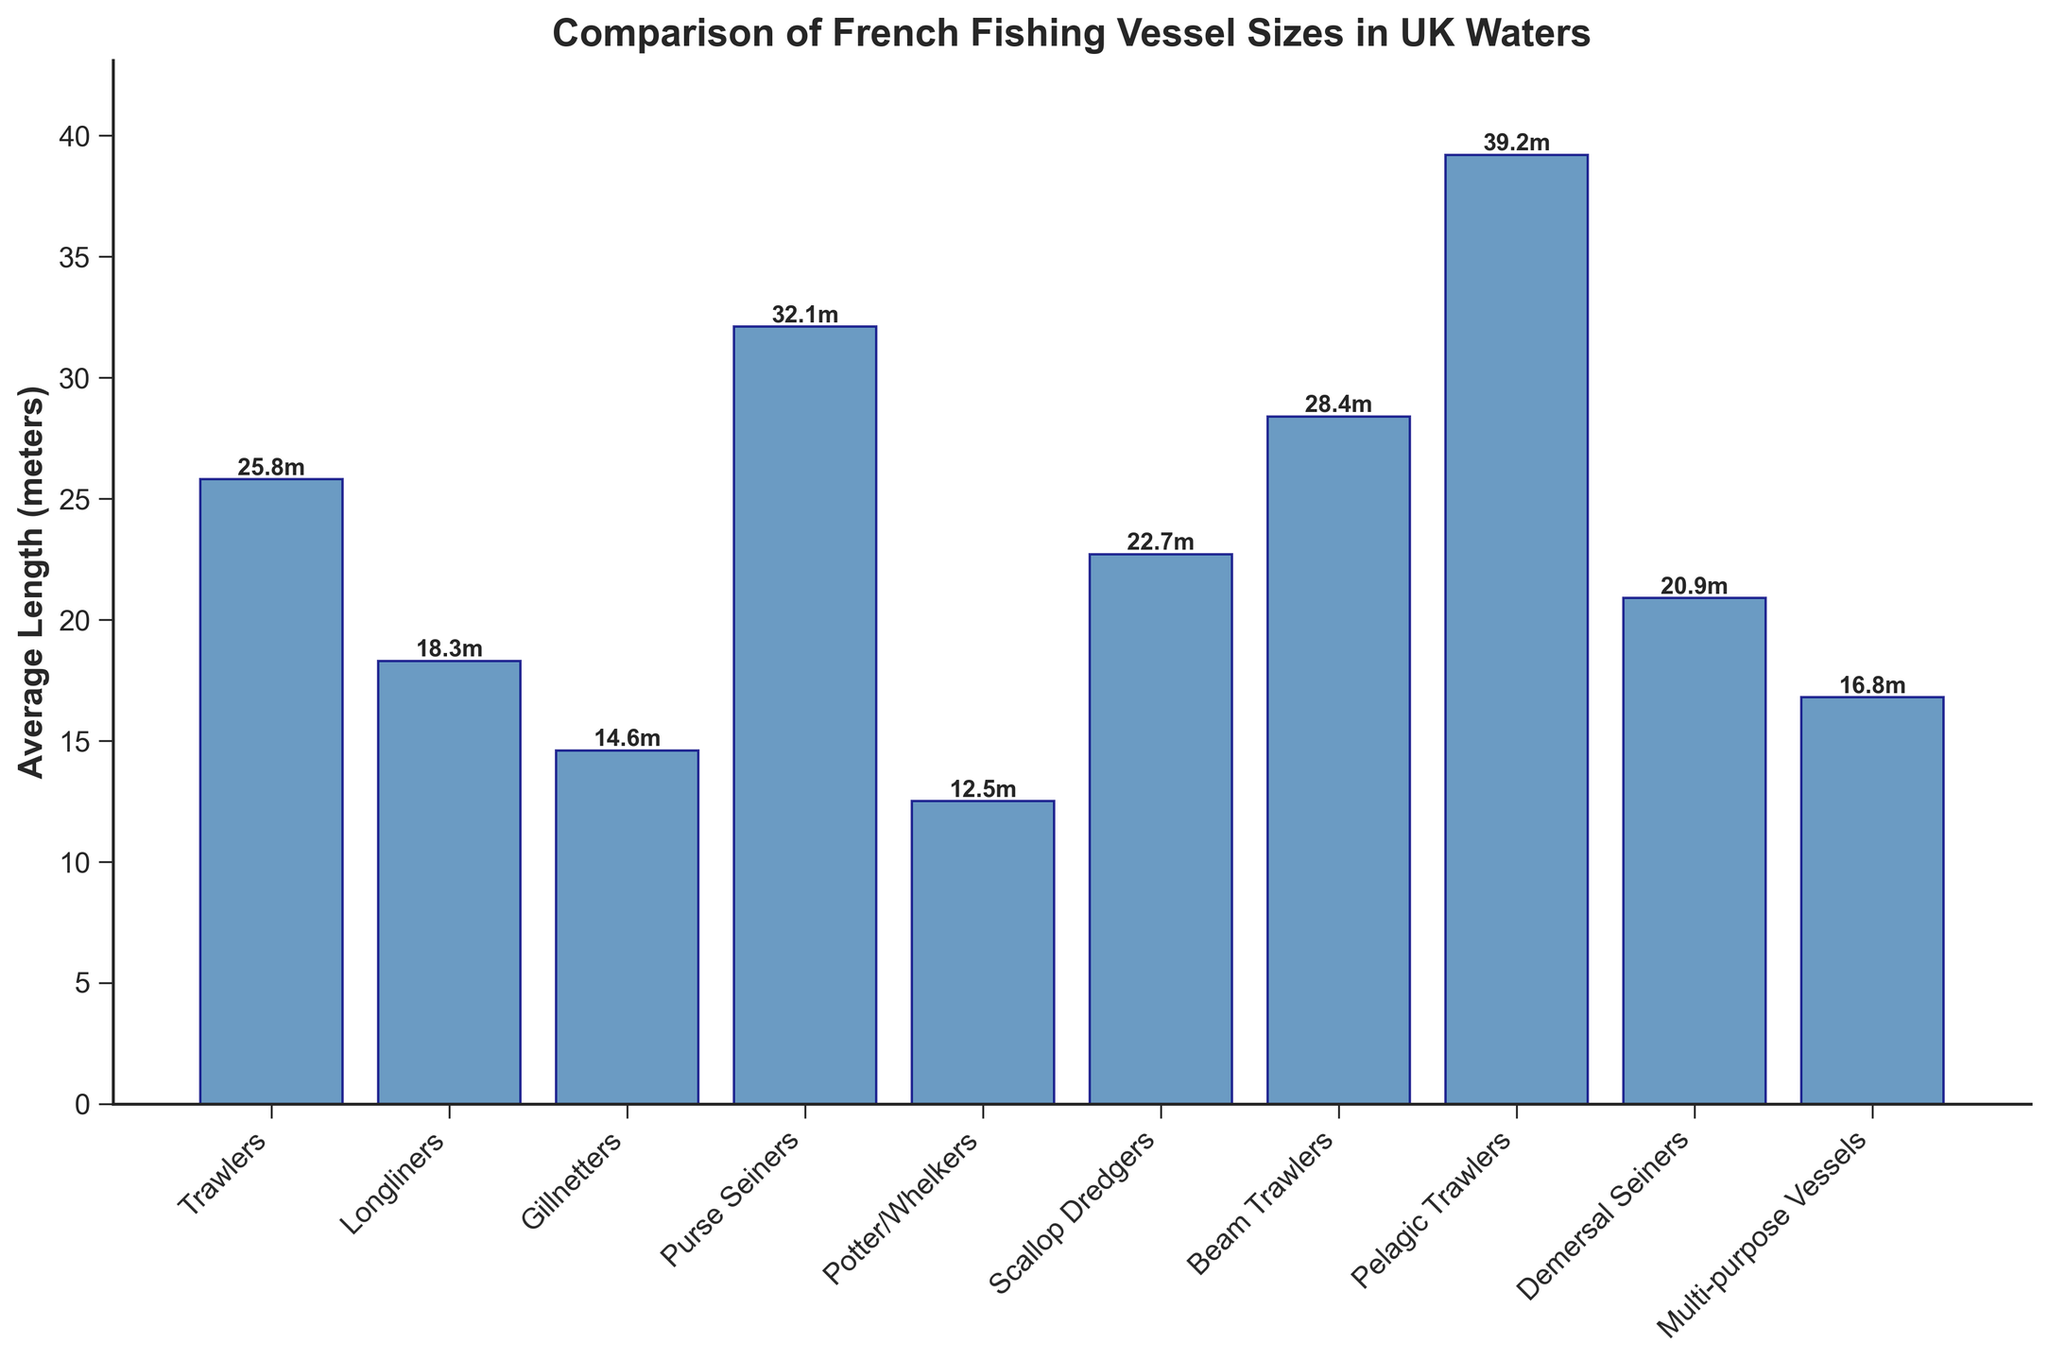What's the average length of the vessels? To calculate the average length, sum up all the average lengths of different vessel types and divide by the number of vessel types. So, (25.8 + 18.3 + 14.6 + 32.1 + 12.5 + 22.7 + 28.4 + 39.2 + 20.9 + 16.8) / 10 = 23.13 meters
Answer: 23.13 meters Which vessel type has the longest average length? By visually inspecting the heights of the bars, the vessel with the longest average length is the one with the tallest bar. The tallest bar represents Pelagic Trawlers with 39.2 meters.
Answer: Pelagic Trawlers How much longer are Pelagic Trawlers on average compared to Potters/Whelkers? Subtract the average length of Potters/Whelkers from the average length of Pelagic Trawlers. Thus, 39.2 - 12.5 = 26.7 meters.
Answer: 26.7 meters Which vessel types have an average length less than 20 meters? Identify bars that are shorter than the 20-meter mark. These vessel types are Potters/Whelkers (12.5), Gillnetters (14.6), Longliners (18.3), and Multi-purpose Vessels (16.8).
Answer: Potters/Whelkers, Gillnetters, Longliners, Multi-purpose Vessels What is the total combined length of Trawlers, Longliners, and Gillnetters? Add the average lengths of Trawlers, Longliners, and Gillnetters. So, 25.8 + 18.3 + 14.6 = 58.7 meters.
Answer: 58.7 meters What is the median length of the vessels? Arrange the vessel lengths in ascending order and find the middle value. The ordered lengths are (12.5, 14.6, 16.8, 18.3, 20.9, 22.7, 25.8, 28.4, 32.1, 39.2). The median is the average of the 5th and 6th values, (20.9 + 22.7) / 2 = 21.8 meters.
Answer: 21.8 meters Are Beam Trawlers longer on average than Demersal Seiners? Compare the average lengths of Beam Trawlers and Demersal Seiners. Beam Trawlers have an average length of 28.4 meters, and Demersal Seiners have an average length of 20.9 meters; hence, Beam Trawlers are longer.
Answer: Yes Which vessel type is approximately halfway in length between Potter/Whelkers and Pelagic Trawlers? Compute the halfway point: (12.5 + 39.2) / 2 = 25.85 meters. The closest vessel type to this length is Trawlers with an average length of 25.8 meters.
Answer: Trawlers What's the difference in length between the longest and shortest vessel types? Subtract the average length of the shortest vessel type (Potters/Whelkers with 12.5 meters) from the longest (Pelagic Trawlers with 39.2 meters). So, 39.2 - 12.5 = 26.7 meters.
Answer: 26.7 meters 